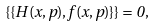<formula> <loc_0><loc_0><loc_500><loc_500>\{ \{ H ( x , p ) , f ( x , p ) \} \} = 0 ,</formula> 